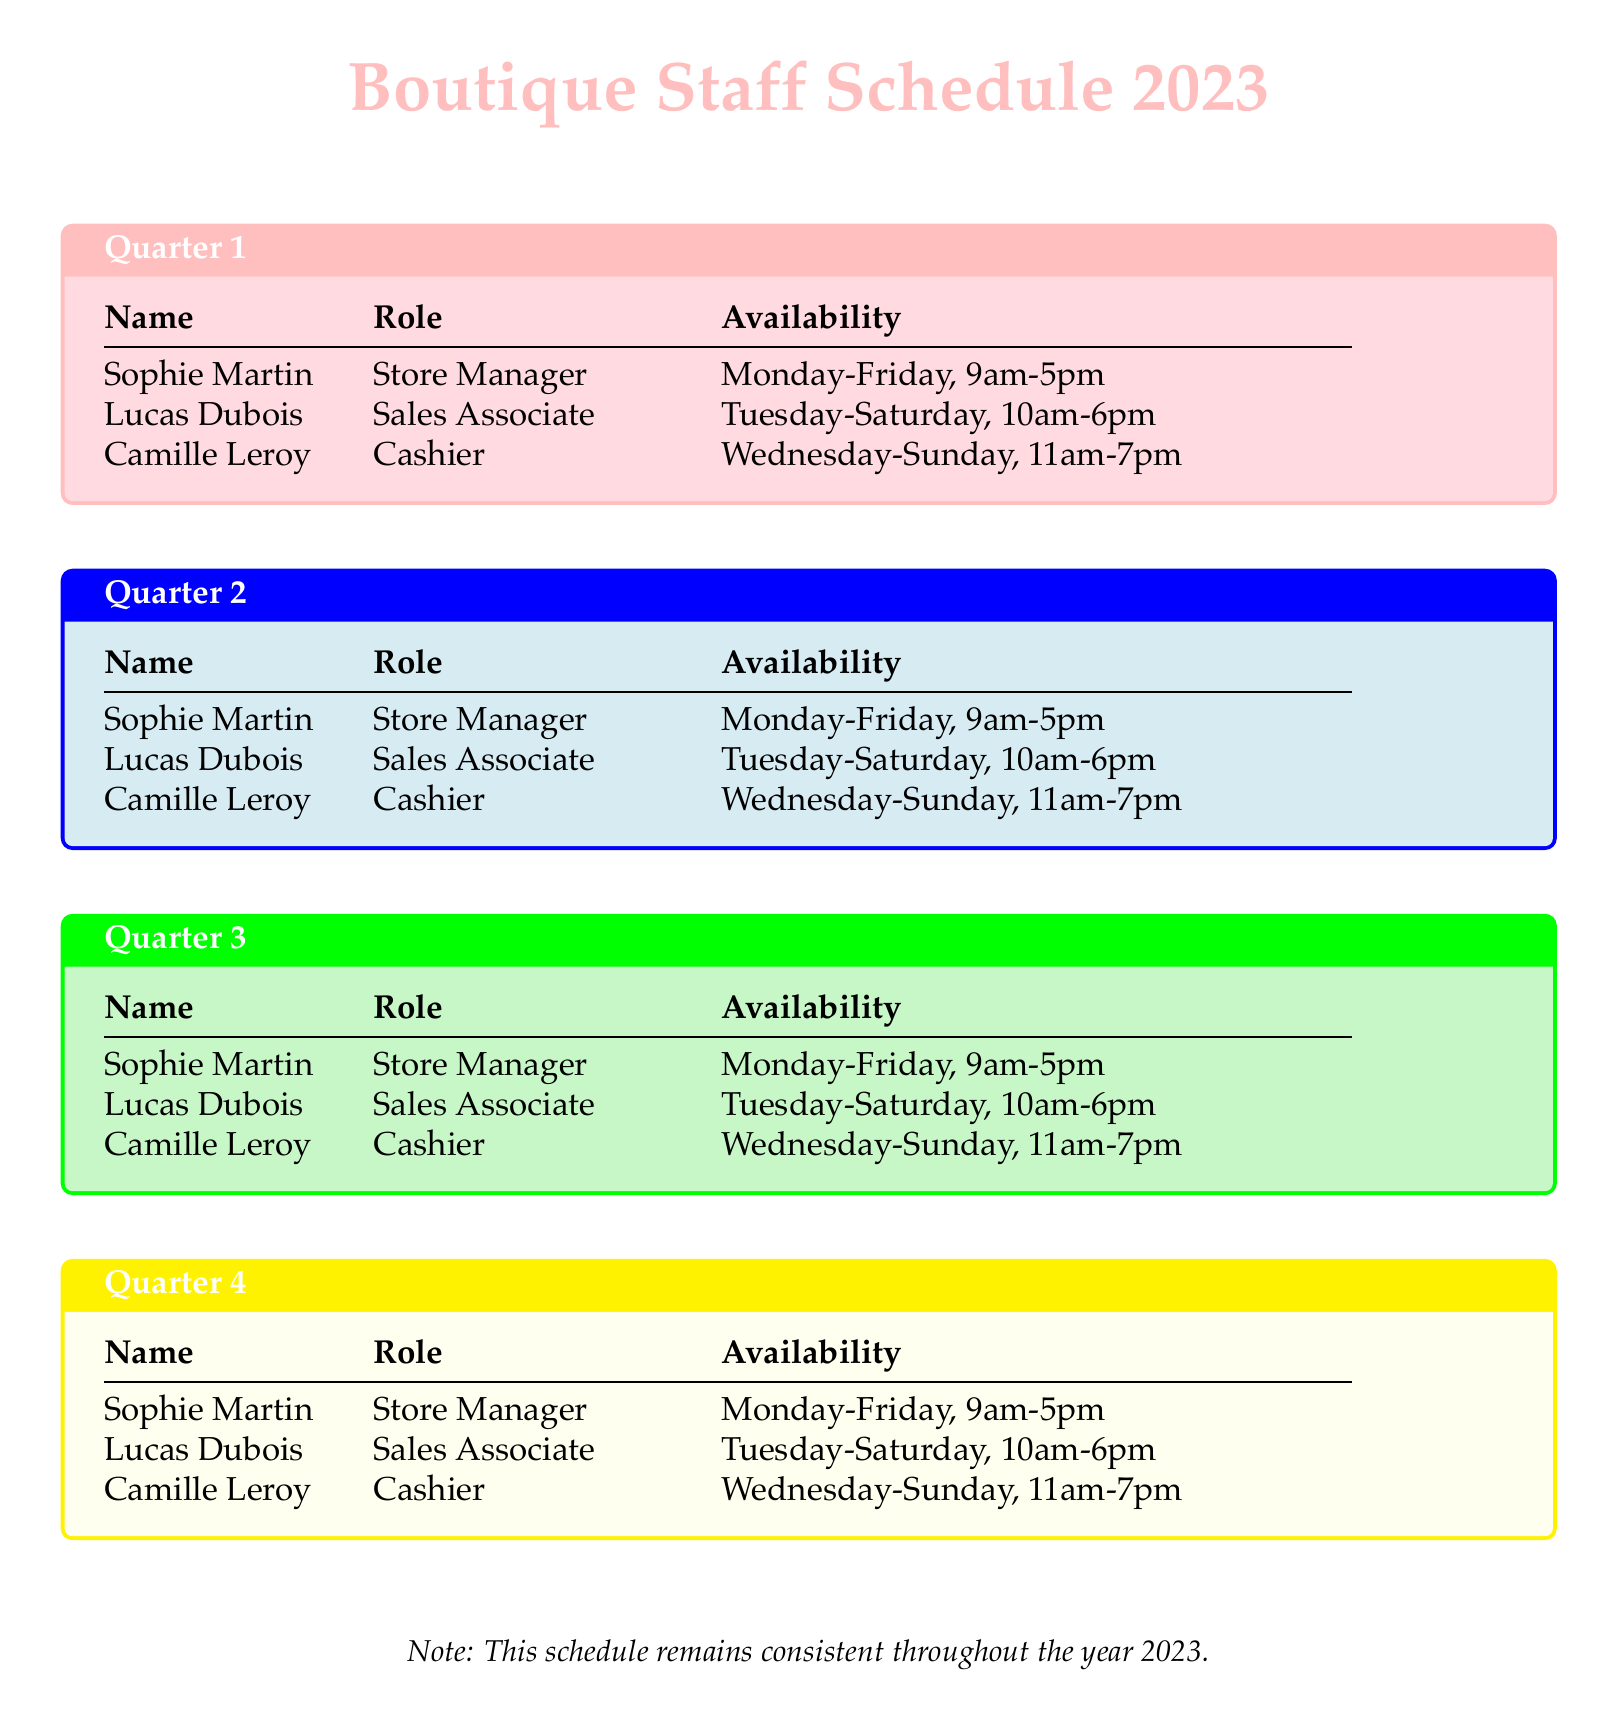What is the name of the store manager? The schedule lists Sophie Martin as the Store Manager.
Answer: Sophie Martin What days is Lucas Dubois available? Lucas Dubois is available from Tuesday to Saturday.
Answer: Tuesday-Saturday How many staff members are mentioned in the schedule? There are three staff members mentioned in the schedule.
Answer: Three What is Camille Leroy's role? Camille Leroy's role is identified as Cashier.
Answer: Cashier In which quarter is the availability schedule consistent? The document states that the schedule remains consistent throughout the entire year 2023.
Answer: Throughout 2023 What are the working hours for Sophie Martin? Sophie Martin's working hours are specified in the schedule: 9am to 5pm.
Answer: 9am-5pm Which staff member works on Sundays? The document indicates that Camille Leroy works on Sundays.
Answer: Camille Leroy What color represents Quarter 3 in the document? The document uses light green to represent Quarter 3.
Answer: Light green What is the availability of Camille Leroy on weekdays? Camille Leroy is available from Wednesday to Sunday, meaning she does not work Monday or Tuesday.
Answer: Wednesday-Sunday 